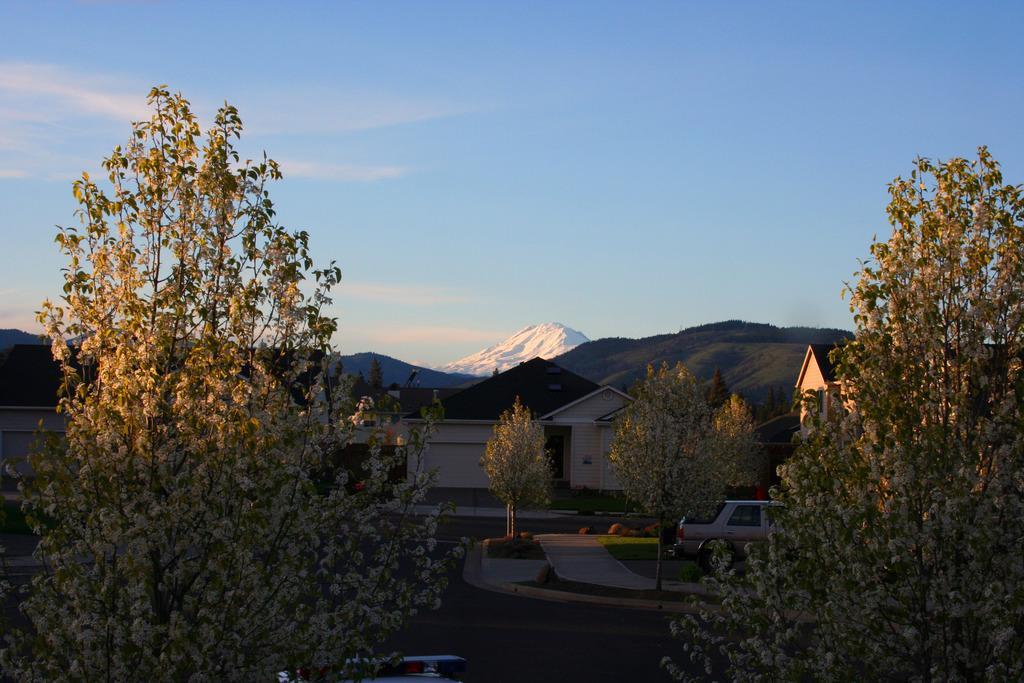Could you give a brief overview of what you see in this image? This is an outside view. Here I can see many trees and buildings. On the right side, I can see a car on the road. In the background there are some hills. At the top I can see the sky. 